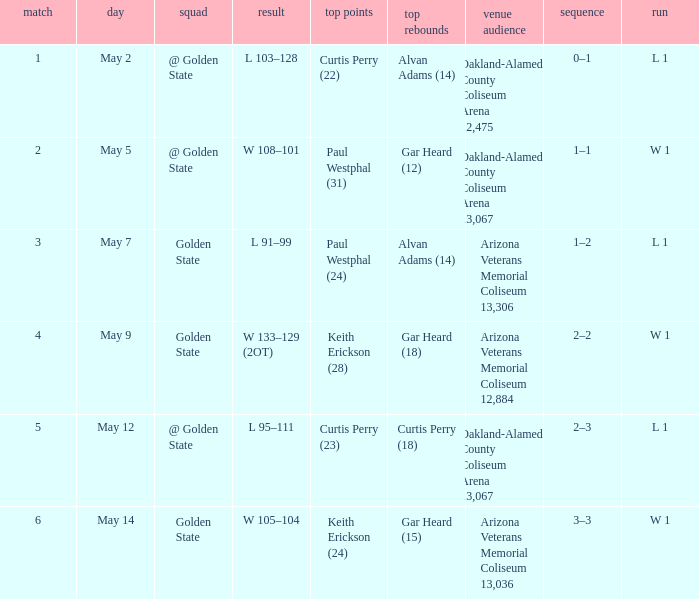How many games had they won or lost in a row on May 9? W 1. 